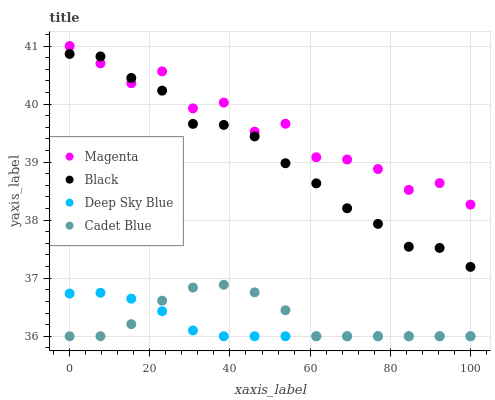Does Deep Sky Blue have the minimum area under the curve?
Answer yes or no. Yes. Does Magenta have the maximum area under the curve?
Answer yes or no. Yes. Does Cadet Blue have the minimum area under the curve?
Answer yes or no. No. Does Cadet Blue have the maximum area under the curve?
Answer yes or no. No. Is Deep Sky Blue the smoothest?
Answer yes or no. Yes. Is Magenta the roughest?
Answer yes or no. Yes. Is Cadet Blue the smoothest?
Answer yes or no. No. Is Cadet Blue the roughest?
Answer yes or no. No. Does Cadet Blue have the lowest value?
Answer yes or no. Yes. Does Black have the lowest value?
Answer yes or no. No. Does Magenta have the highest value?
Answer yes or no. Yes. Does Cadet Blue have the highest value?
Answer yes or no. No. Is Cadet Blue less than Black?
Answer yes or no. Yes. Is Magenta greater than Cadet Blue?
Answer yes or no. Yes. Does Cadet Blue intersect Deep Sky Blue?
Answer yes or no. Yes. Is Cadet Blue less than Deep Sky Blue?
Answer yes or no. No. Is Cadet Blue greater than Deep Sky Blue?
Answer yes or no. No. Does Cadet Blue intersect Black?
Answer yes or no. No. 